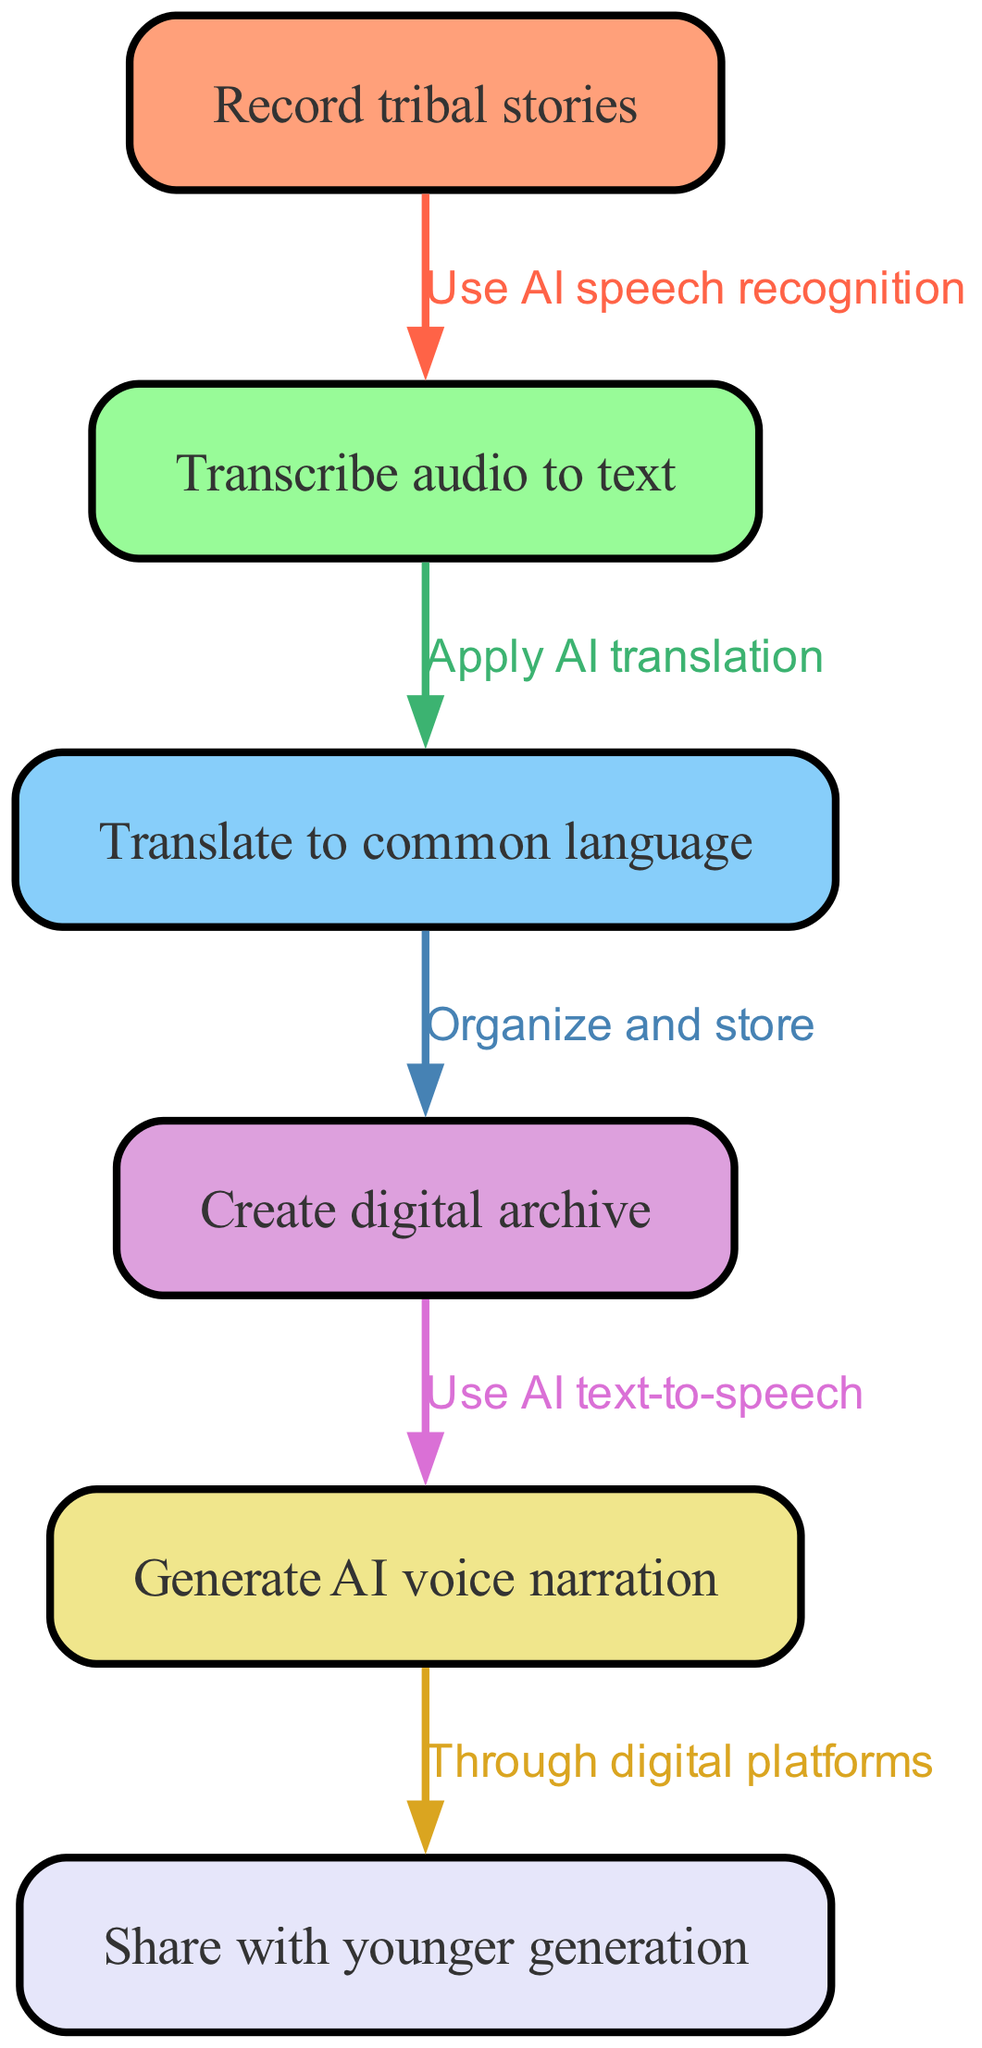What is the first step in the workflow? The first step in the workflow is to "Record tribal stories," as indicated by the first node in the diagram.
Answer: Record tribal stories How many nodes are present in the diagram? By counting each distinct rectangle representing a node, there are a total of six nodes in the diagram: recording stories, transcription, translation, archiving, narration, and sharing.
Answer: 6 What action is used to transcribe audio to text? The action used to transcribe audio to text is "Use AI speech recognition," which is the label on the edge connecting the first and second nodes.
Answer: Use AI speech recognition What is the relationship between "Translate to common language" and "Create digital archive"? The relationship is that you "Organize and store" after translating to create a digital archive, as seen in the edge connecting the third and fourth nodes.
Answer: Organize and store Which node follows "Generate AI voice narration"? The node that follows "Generate AI voice narration" is "Share with younger generation," as indicated by the edge going from the fifth to the sixth node.
Answer: Share with younger generation What technology is applied to translate the text to a common language? The technology applied is "Apply AI translation," which appears as the edge connecting the second and third nodes.
Answer: Apply AI translation What is the last step in this workflow? The last step in the workflow is "Share with younger generation," which is the final node in the sequence of actions.
Answer: Share with younger generation How many edges connect the nodes in this diagram? By counting the lines connecting the nodes, there are a total of five edges depicted in the diagram.
Answer: 5 What is used to create a digital archive? To create a digital archive, you need to "Organize and store" the translated texts, as stated in the edge linking the third and fourth nodes.
Answer: Organize and store 